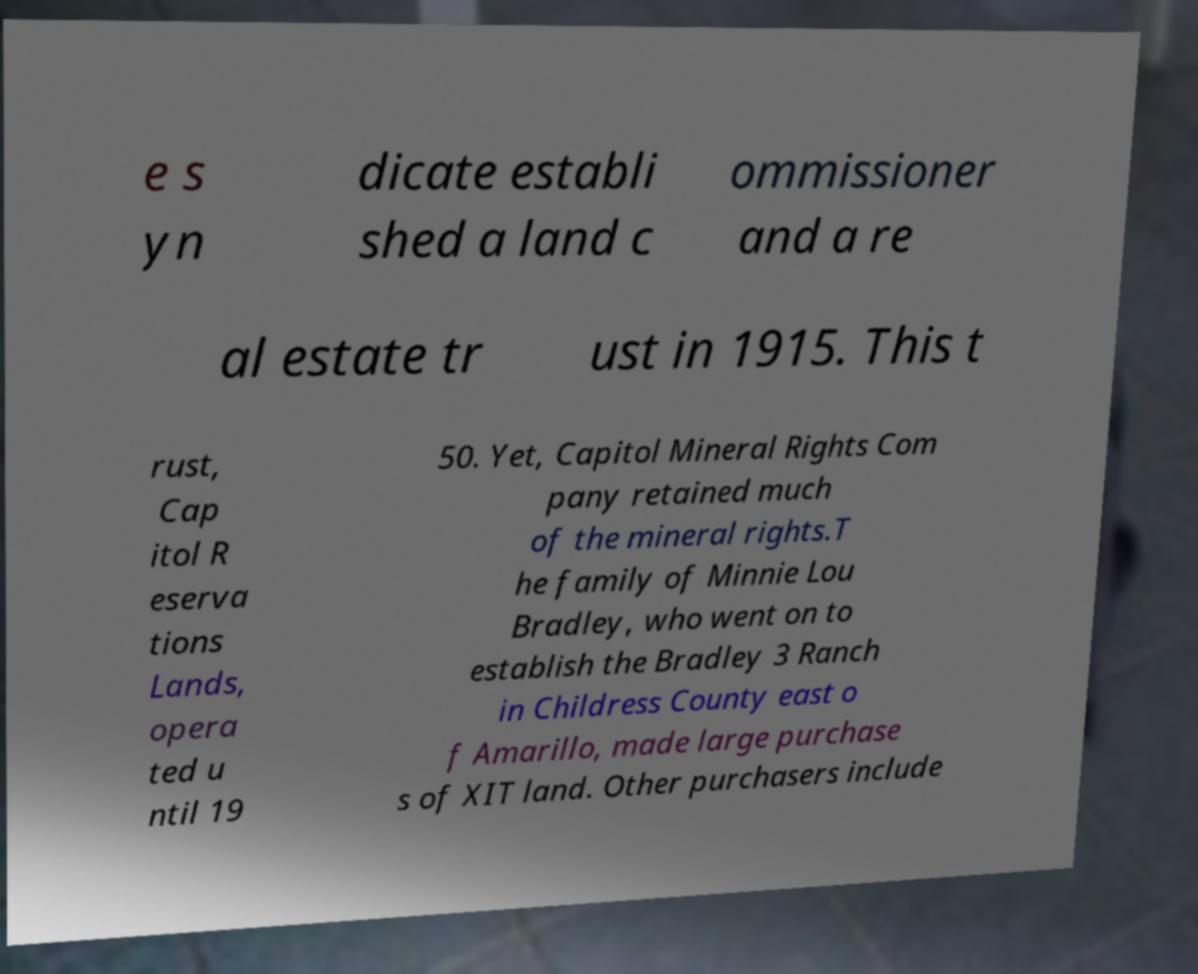Can you accurately transcribe the text from the provided image for me? e s yn dicate establi shed a land c ommissioner and a re al estate tr ust in 1915. This t rust, Cap itol R eserva tions Lands, opera ted u ntil 19 50. Yet, Capitol Mineral Rights Com pany retained much of the mineral rights.T he family of Minnie Lou Bradley, who went on to establish the Bradley 3 Ranch in Childress County east o f Amarillo, made large purchase s of XIT land. Other purchasers include 